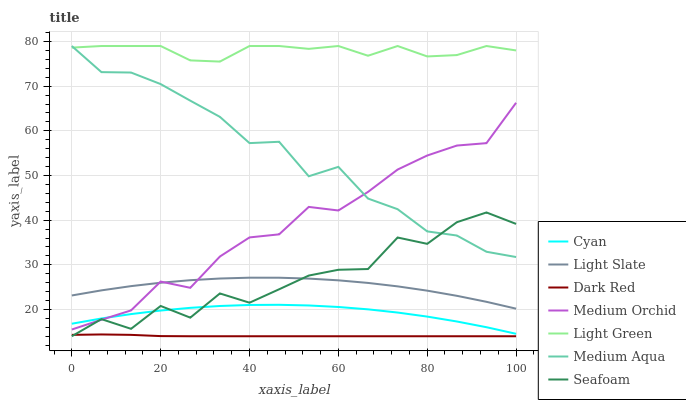Does Dark Red have the minimum area under the curve?
Answer yes or no. Yes. Does Light Green have the maximum area under the curve?
Answer yes or no. Yes. Does Medium Orchid have the minimum area under the curve?
Answer yes or no. No. Does Medium Orchid have the maximum area under the curve?
Answer yes or no. No. Is Dark Red the smoothest?
Answer yes or no. Yes. Is Seafoam the roughest?
Answer yes or no. Yes. Is Medium Orchid the smoothest?
Answer yes or no. No. Is Medium Orchid the roughest?
Answer yes or no. No. Does Medium Orchid have the lowest value?
Answer yes or no. No. Does Light Green have the highest value?
Answer yes or no. Yes. Does Medium Orchid have the highest value?
Answer yes or no. No. Is Dark Red less than Cyan?
Answer yes or no. Yes. Is Light Slate greater than Cyan?
Answer yes or no. Yes. Does Seafoam intersect Dark Red?
Answer yes or no. Yes. Is Seafoam less than Dark Red?
Answer yes or no. No. Is Seafoam greater than Dark Red?
Answer yes or no. No. Does Dark Red intersect Cyan?
Answer yes or no. No. 